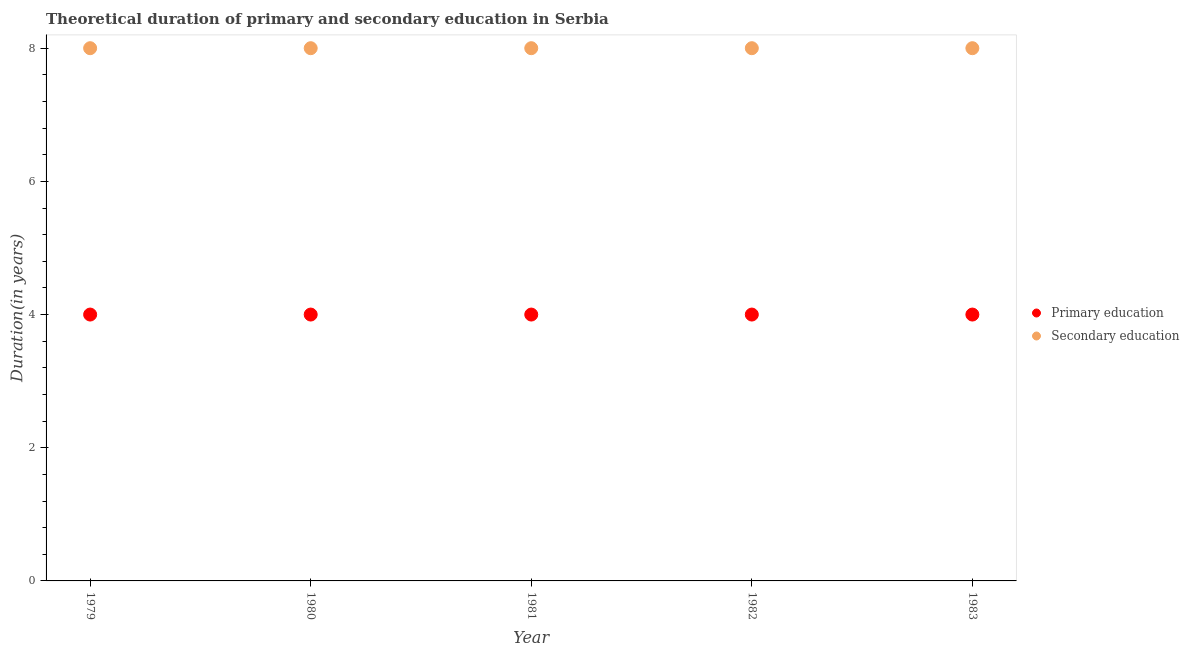What is the duration of primary education in 1982?
Your response must be concise. 4. Across all years, what is the maximum duration of secondary education?
Your response must be concise. 8. Across all years, what is the minimum duration of secondary education?
Ensure brevity in your answer.  8. In which year was the duration of primary education maximum?
Your answer should be compact. 1979. In which year was the duration of secondary education minimum?
Provide a short and direct response. 1979. What is the total duration of primary education in the graph?
Keep it short and to the point. 20. What is the difference between the duration of primary education in 1982 and the duration of secondary education in 1983?
Your answer should be compact. -4. In the year 1979, what is the difference between the duration of secondary education and duration of primary education?
Your response must be concise. 4. In how many years, is the duration of primary education greater than 4 years?
Provide a short and direct response. 0. What is the ratio of the duration of primary education in 1979 to that in 1980?
Provide a short and direct response. 1. Is the duration of primary education in 1981 less than that in 1982?
Give a very brief answer. No. Is the difference between the duration of secondary education in 1979 and 1983 greater than the difference between the duration of primary education in 1979 and 1983?
Your answer should be very brief. No. What is the difference between the highest and the second highest duration of primary education?
Offer a terse response. 0. Is the sum of the duration of secondary education in 1979 and 1981 greater than the maximum duration of primary education across all years?
Make the answer very short. Yes. How many dotlines are there?
Keep it short and to the point. 2. How many years are there in the graph?
Your response must be concise. 5. What is the difference between two consecutive major ticks on the Y-axis?
Give a very brief answer. 2. Are the values on the major ticks of Y-axis written in scientific E-notation?
Your answer should be very brief. No. Does the graph contain any zero values?
Your response must be concise. No. Does the graph contain grids?
Make the answer very short. No. How many legend labels are there?
Make the answer very short. 2. How are the legend labels stacked?
Your response must be concise. Vertical. What is the title of the graph?
Your answer should be very brief. Theoretical duration of primary and secondary education in Serbia. What is the label or title of the X-axis?
Your answer should be compact. Year. What is the label or title of the Y-axis?
Your answer should be very brief. Duration(in years). What is the Duration(in years) in Primary education in 1980?
Your answer should be compact. 4. What is the Duration(in years) in Secondary education in 1981?
Keep it short and to the point. 8. What is the Duration(in years) in Secondary education in 1982?
Provide a short and direct response. 8. What is the Duration(in years) in Primary education in 1983?
Provide a short and direct response. 4. What is the Duration(in years) in Secondary education in 1983?
Ensure brevity in your answer.  8. Across all years, what is the maximum Duration(in years) of Primary education?
Ensure brevity in your answer.  4. Across all years, what is the minimum Duration(in years) of Primary education?
Give a very brief answer. 4. Across all years, what is the minimum Duration(in years) in Secondary education?
Make the answer very short. 8. What is the total Duration(in years) of Primary education in the graph?
Provide a succinct answer. 20. What is the total Duration(in years) in Secondary education in the graph?
Your answer should be compact. 40. What is the difference between the Duration(in years) in Primary education in 1979 and that in 1980?
Keep it short and to the point. 0. What is the difference between the Duration(in years) of Primary education in 1979 and that in 1981?
Your answer should be very brief. 0. What is the difference between the Duration(in years) of Secondary education in 1979 and that in 1981?
Make the answer very short. 0. What is the difference between the Duration(in years) of Secondary education in 1979 and that in 1982?
Give a very brief answer. 0. What is the difference between the Duration(in years) of Primary education in 1979 and that in 1983?
Give a very brief answer. 0. What is the difference between the Duration(in years) in Secondary education in 1980 and that in 1981?
Ensure brevity in your answer.  0. What is the difference between the Duration(in years) in Primary education in 1980 and that in 1982?
Provide a succinct answer. 0. What is the difference between the Duration(in years) in Secondary education in 1980 and that in 1982?
Provide a short and direct response. 0. What is the difference between the Duration(in years) in Primary education in 1980 and that in 1983?
Make the answer very short. 0. What is the difference between the Duration(in years) of Primary education in 1981 and that in 1983?
Give a very brief answer. 0. What is the difference between the Duration(in years) in Secondary education in 1981 and that in 1983?
Offer a terse response. 0. What is the difference between the Duration(in years) of Primary education in 1982 and that in 1983?
Ensure brevity in your answer.  0. What is the difference between the Duration(in years) in Primary education in 1979 and the Duration(in years) in Secondary education in 1980?
Your answer should be very brief. -4. What is the difference between the Duration(in years) of Primary education in 1979 and the Duration(in years) of Secondary education in 1981?
Keep it short and to the point. -4. What is the difference between the Duration(in years) in Primary education in 1979 and the Duration(in years) in Secondary education in 1982?
Make the answer very short. -4. What is the difference between the Duration(in years) in Primary education in 1980 and the Duration(in years) in Secondary education in 1983?
Make the answer very short. -4. What is the difference between the Duration(in years) of Primary education in 1981 and the Duration(in years) of Secondary education in 1982?
Offer a terse response. -4. What is the difference between the Duration(in years) in Primary education in 1982 and the Duration(in years) in Secondary education in 1983?
Provide a short and direct response. -4. In the year 1979, what is the difference between the Duration(in years) in Primary education and Duration(in years) in Secondary education?
Your answer should be very brief. -4. In the year 1980, what is the difference between the Duration(in years) of Primary education and Duration(in years) of Secondary education?
Make the answer very short. -4. In the year 1981, what is the difference between the Duration(in years) in Primary education and Duration(in years) in Secondary education?
Your answer should be very brief. -4. In the year 1982, what is the difference between the Duration(in years) of Primary education and Duration(in years) of Secondary education?
Your answer should be very brief. -4. In the year 1983, what is the difference between the Duration(in years) of Primary education and Duration(in years) of Secondary education?
Provide a short and direct response. -4. What is the ratio of the Duration(in years) in Primary education in 1979 to that in 1980?
Offer a terse response. 1. What is the ratio of the Duration(in years) in Secondary education in 1979 to that in 1980?
Keep it short and to the point. 1. What is the ratio of the Duration(in years) in Secondary education in 1979 to that in 1981?
Your answer should be very brief. 1. What is the ratio of the Duration(in years) in Primary education in 1979 to that in 1982?
Keep it short and to the point. 1. What is the ratio of the Duration(in years) of Secondary education in 1979 to that in 1983?
Give a very brief answer. 1. What is the ratio of the Duration(in years) in Primary education in 1980 to that in 1981?
Your response must be concise. 1. What is the ratio of the Duration(in years) in Primary education in 1980 to that in 1982?
Offer a terse response. 1. What is the ratio of the Duration(in years) of Secondary education in 1980 to that in 1982?
Provide a succinct answer. 1. What is the ratio of the Duration(in years) in Primary education in 1981 to that in 1982?
Offer a terse response. 1. What is the ratio of the Duration(in years) of Secondary education in 1981 to that in 1982?
Provide a succinct answer. 1. What is the ratio of the Duration(in years) in Primary education in 1981 to that in 1983?
Give a very brief answer. 1. What is the ratio of the Duration(in years) in Secondary education in 1981 to that in 1983?
Provide a short and direct response. 1. What is the difference between the highest and the second highest Duration(in years) of Secondary education?
Ensure brevity in your answer.  0. What is the difference between the highest and the lowest Duration(in years) of Primary education?
Offer a terse response. 0. 